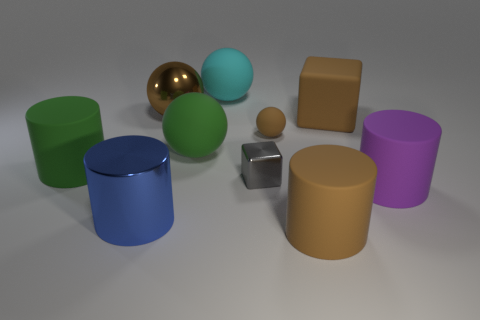What shape is the metal thing that is behind the block that is behind the big green sphere?
Ensure brevity in your answer.  Sphere. There is a brown ball that is in front of the brown rubber thing that is to the right of the matte object in front of the purple rubber cylinder; what is its size?
Offer a terse response. Small. Is the size of the cyan rubber thing the same as the gray object?
Make the answer very short. No. What number of objects are large matte things or matte balls?
Keep it short and to the point. 7. There is a block to the left of the small thing right of the small cube; what is its size?
Offer a very short reply. Small. The cyan object is what size?
Offer a very short reply. Large. The big brown thing that is both to the right of the small metal block and behind the blue shiny thing has what shape?
Offer a very short reply. Cube. The metallic thing that is the same shape as the large purple matte thing is what color?
Offer a very short reply. Blue. How many objects are either big cylinders that are to the left of the tiny sphere or brown things right of the cyan rubber thing?
Your answer should be very brief. 5. What is the shape of the cyan rubber object?
Keep it short and to the point. Sphere. 